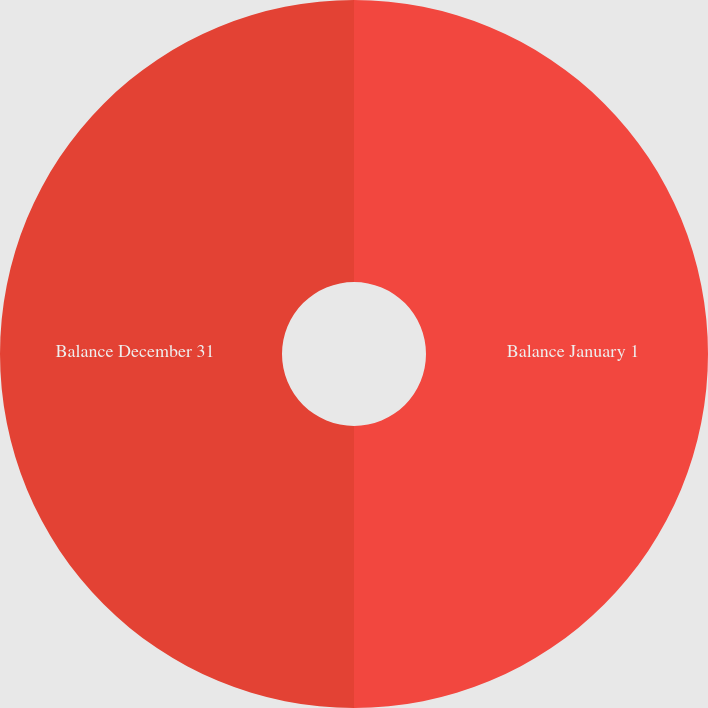Convert chart to OTSL. <chart><loc_0><loc_0><loc_500><loc_500><pie_chart><fcel>Balance January 1<fcel>Balance December 31<nl><fcel>50.0%<fcel>50.0%<nl></chart> 